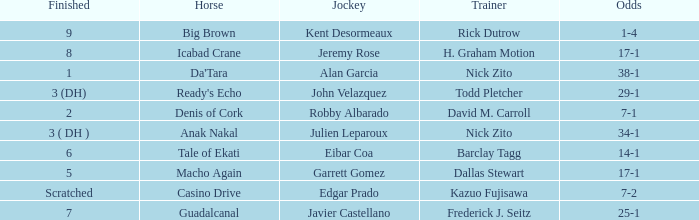What are the Odds for the Horse called Ready's Echo? 29-1. 